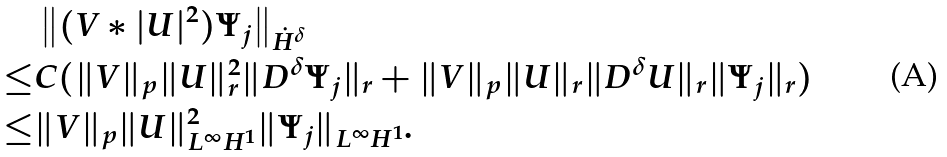<formula> <loc_0><loc_0><loc_500><loc_500>& \left \| ( V * | U | ^ { 2 } ) \Psi _ { j } \right \| _ { \dot { H } ^ { \delta } } \\ \leq & C ( \| V \| _ { p } \| U \| _ { r } ^ { 2 } \| D ^ { \delta } \Psi _ { j } \| _ { r } + \| V \| _ { p } \| U \| _ { r } \| D ^ { \delta } U \| _ { r } \| \Psi _ { j } \| _ { r } ) \\ \leq & \| V \| _ { p } \| U \| ^ { 2 } _ { L ^ { \infty } H ^ { 1 } } \| \Psi _ { j } \| _ { L ^ { \infty } H ^ { 1 } } .</formula> 